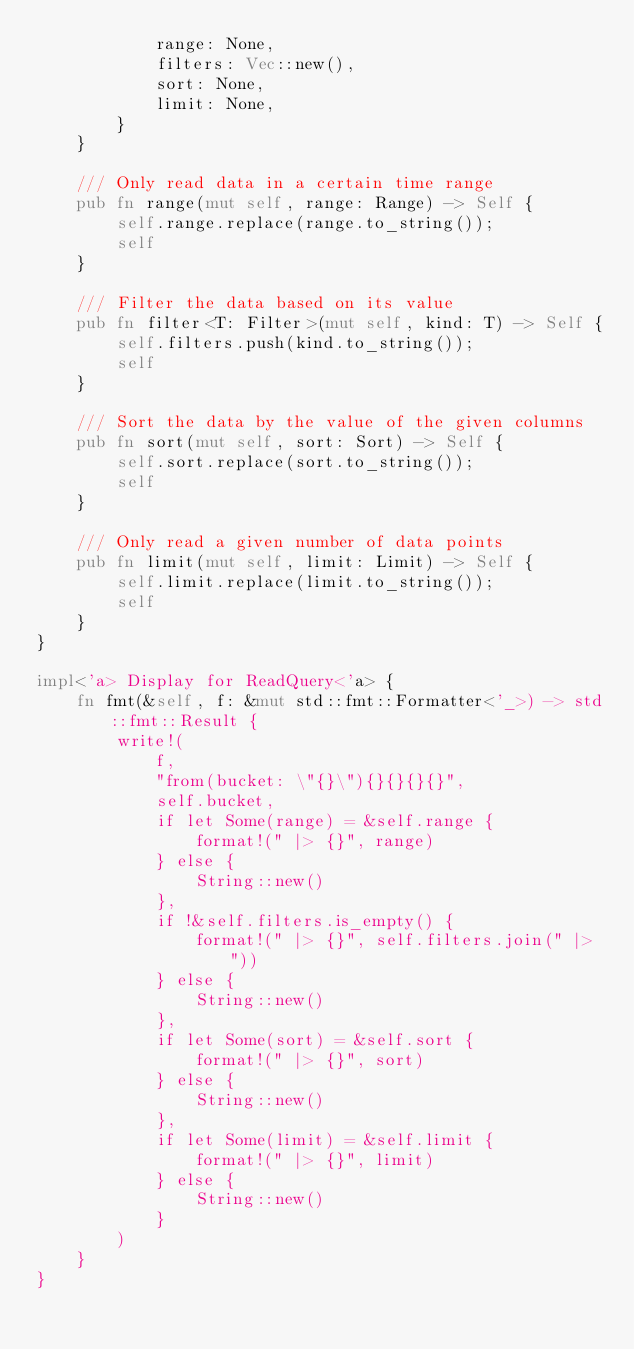<code> <loc_0><loc_0><loc_500><loc_500><_Rust_>            range: None,
            filters: Vec::new(),
            sort: None,
            limit: None,
        }
    }

    /// Only read data in a certain time range
    pub fn range(mut self, range: Range) -> Self {
        self.range.replace(range.to_string());
        self
    }

    /// Filter the data based on its value
    pub fn filter<T: Filter>(mut self, kind: T) -> Self {
        self.filters.push(kind.to_string());
        self
    }

    /// Sort the data by the value of the given columns
    pub fn sort(mut self, sort: Sort) -> Self {
        self.sort.replace(sort.to_string());
        self
    }

    /// Only read a given number of data points
    pub fn limit(mut self, limit: Limit) -> Self {
        self.limit.replace(limit.to_string());
        self
    }
}

impl<'a> Display for ReadQuery<'a> {
    fn fmt(&self, f: &mut std::fmt::Formatter<'_>) -> std::fmt::Result {
        write!(
            f,
            "from(bucket: \"{}\"){}{}{}{}",
            self.bucket,
            if let Some(range) = &self.range {
                format!(" |> {}", range)
            } else {
                String::new()
            },
            if !&self.filters.is_empty() {
                format!(" |> {}", self.filters.join(" |> "))
            } else {
                String::new()
            },
            if let Some(sort) = &self.sort {
                format!(" |> {}", sort)
            } else {
                String::new()
            },
            if let Some(limit) = &self.limit {
                format!(" |> {}", limit)
            } else {
                String::new()
            }
        )
    }
}
</code> 